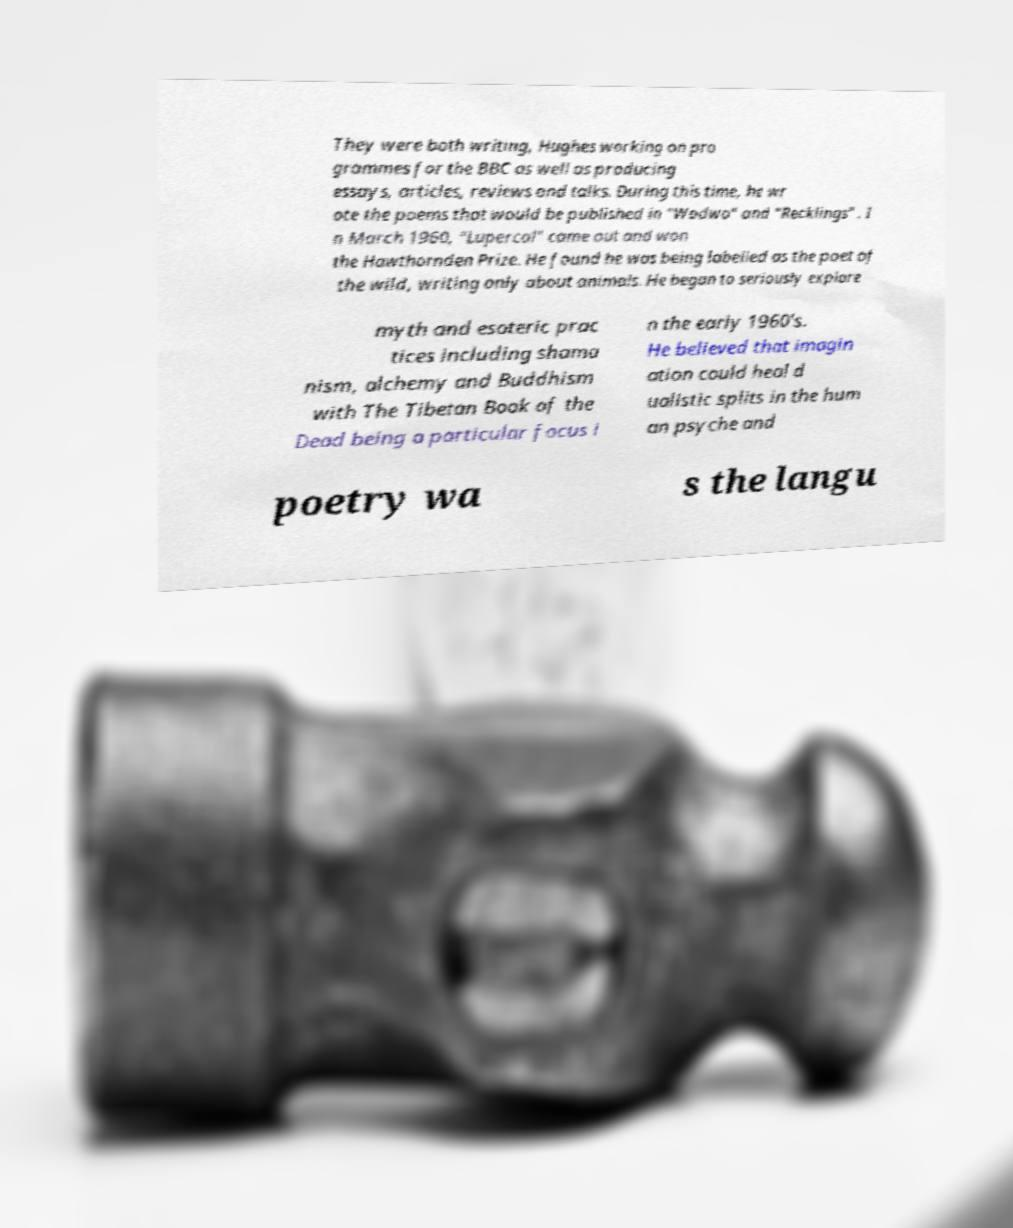Please read and relay the text visible in this image. What does it say? They were both writing, Hughes working on pro grammes for the BBC as well as producing essays, articles, reviews and talks. During this time, he wr ote the poems that would be published in "Wodwo" and "Recklings" . I n March 1960, "Lupercal" came out and won the Hawthornden Prize. He found he was being labelled as the poet of the wild, writing only about animals. He began to seriously explore myth and esoteric prac tices including shama nism, alchemy and Buddhism with The Tibetan Book of the Dead being a particular focus i n the early 1960’s. He believed that imagin ation could heal d ualistic splits in the hum an psyche and poetry wa s the langu 